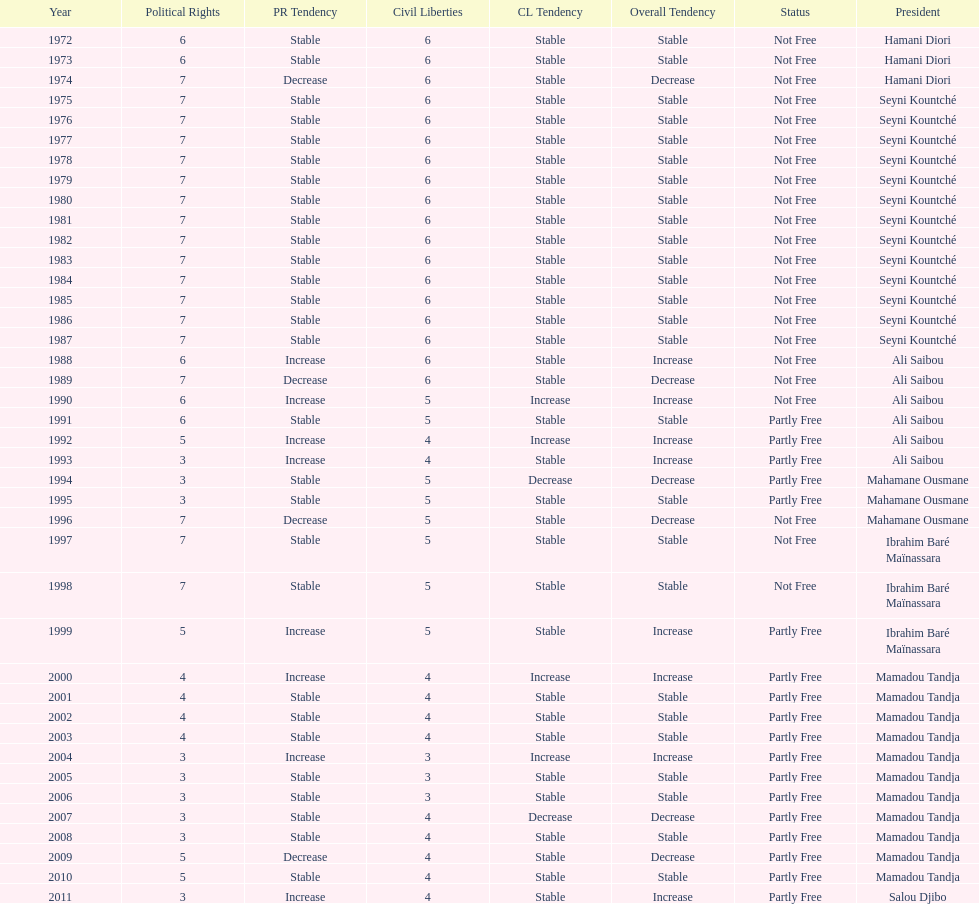How many years was it before the first partly free status? 18. 